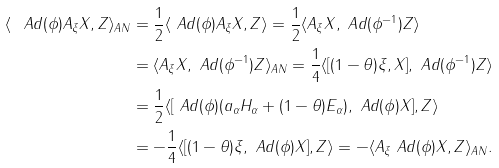Convert formula to latex. <formula><loc_0><loc_0><loc_500><loc_500>\langle \ A d ( \phi ) A _ { \xi } X , Z \rangle _ { A N } & = \frac { 1 } { 2 } \langle \ A d ( \phi ) A _ { \xi } X , Z \rangle = \frac { 1 } { 2 } \langle A _ { \xi } X , \ A d ( \phi ^ { - 1 } ) Z \rangle \\ & = \langle A _ { \xi } X , \ A d ( \phi ^ { - 1 } ) Z \rangle _ { A N } = \frac { 1 } { 4 } \langle [ ( 1 - \theta ) \xi , X ] , \ A d ( \phi ^ { - 1 } ) Z \rangle \\ & = \frac { 1 } { 2 } \langle [ \ A d ( \phi ) ( a _ { \alpha } H _ { \alpha } + ( 1 - \theta ) E _ { \alpha } ) , \ A d ( \phi ) X ] , Z \rangle \\ & = - \frac { 1 } { 4 } \langle [ ( 1 - \theta ) \xi , \ A d ( \phi ) X ] , Z \rangle = - \langle A _ { \xi } \ A d ( \phi ) X , Z \rangle _ { A N } .</formula> 